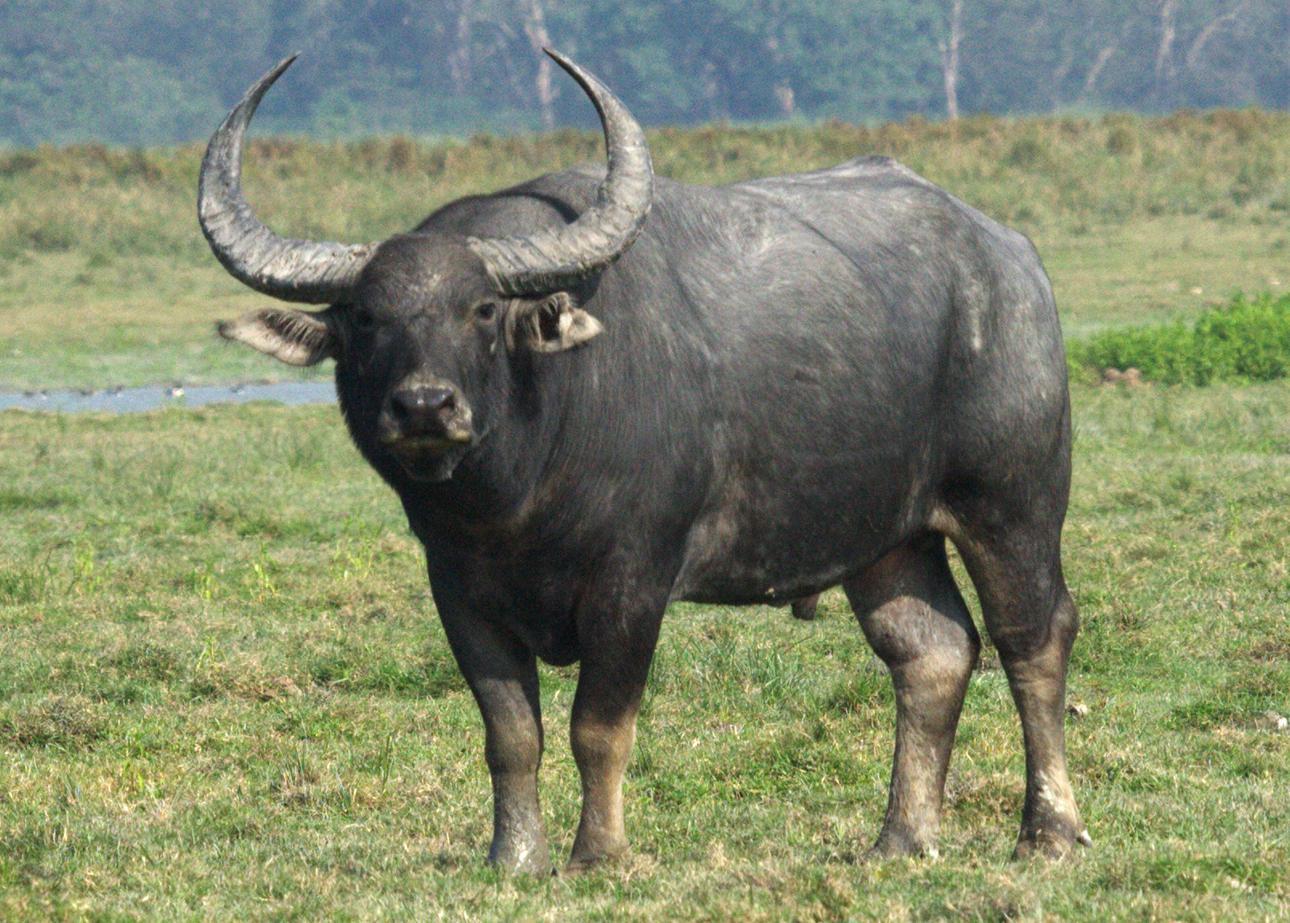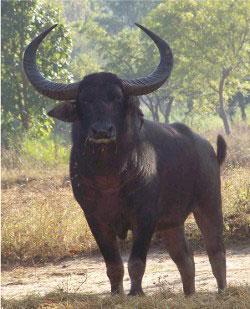The first image is the image on the left, the second image is the image on the right. Examine the images to the left and right. Is the description "No other animal is pictured except for two bulls." accurate? Answer yes or no. Yes. 